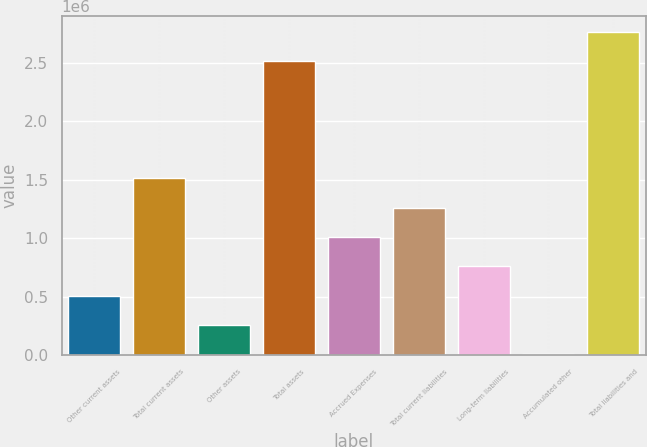Convert chart. <chart><loc_0><loc_0><loc_500><loc_500><bar_chart><fcel>Other current assets<fcel>Total current assets<fcel>Other assets<fcel>Total assets<fcel>Accrued Expenses<fcel>Total current liabilities<fcel>Long-term liabilities<fcel>Accumulated other<fcel>Total liabilities and<nl><fcel>507616<fcel>1.50897e+06<fcel>257278<fcel>2.51032e+06<fcel>1.00829e+06<fcel>1.25863e+06<fcel>757955<fcel>6940<fcel>2.76066e+06<nl></chart> 